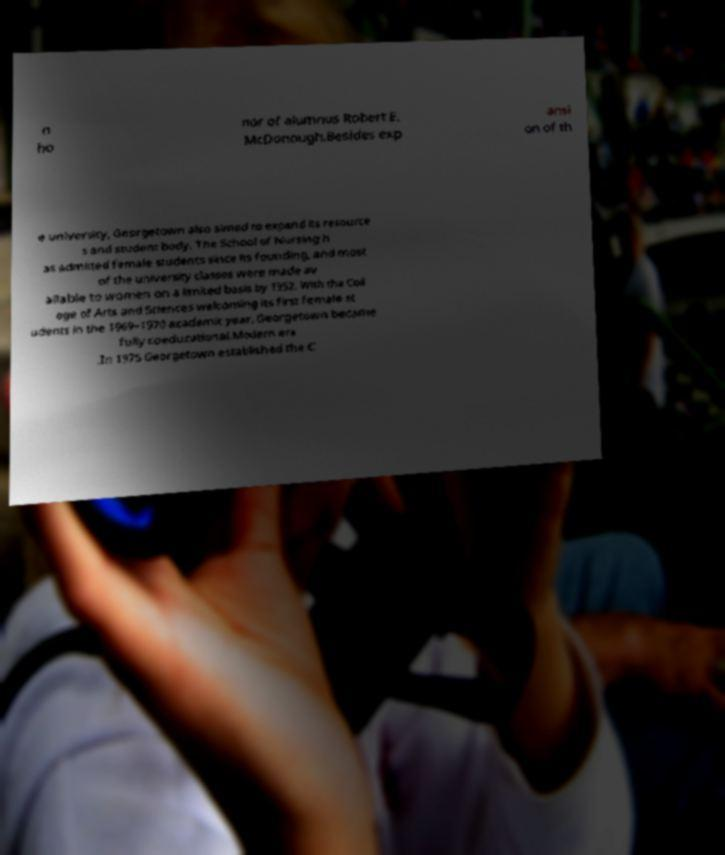I need the written content from this picture converted into text. Can you do that? n ho nor of alumnus Robert E. McDonough.Besides exp ansi on of th e university, Georgetown also aimed to expand its resource s and student body. The School of Nursing h as admitted female students since its founding, and most of the university classes were made av ailable to women on a limited basis by 1952. With the Coll ege of Arts and Sciences welcoming its first female st udents in the 1969–1970 academic year, Georgetown became fully coeducational.Modern era .In 1975 Georgetown established the C 